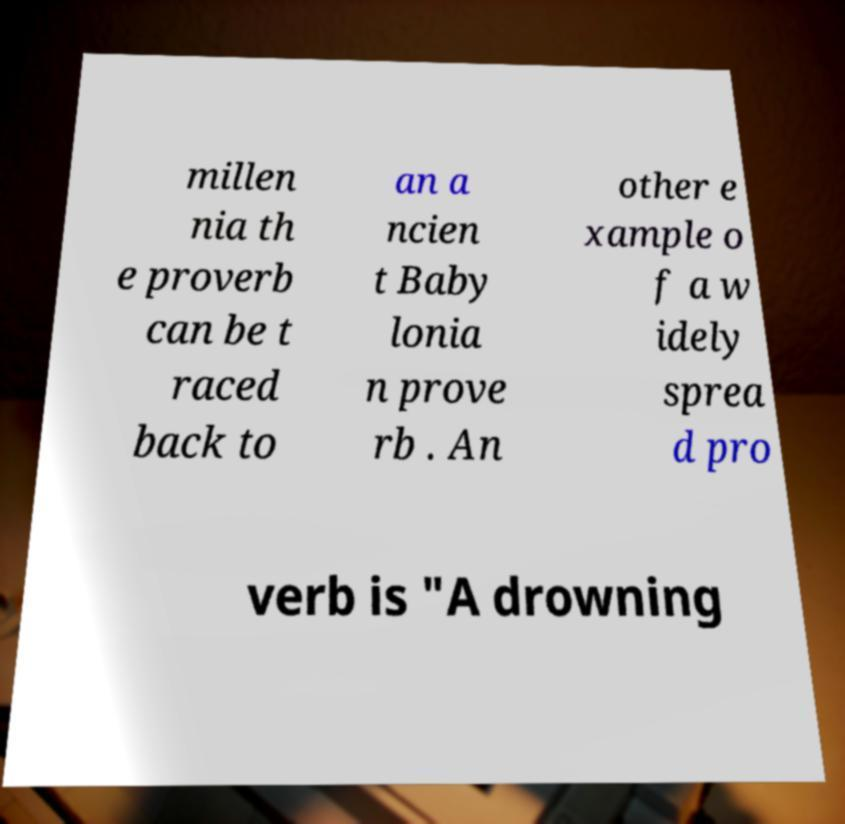Please read and relay the text visible in this image. What does it say? millen nia th e proverb can be t raced back to an a ncien t Baby lonia n prove rb . An other e xample o f a w idely sprea d pro verb is "A drowning 